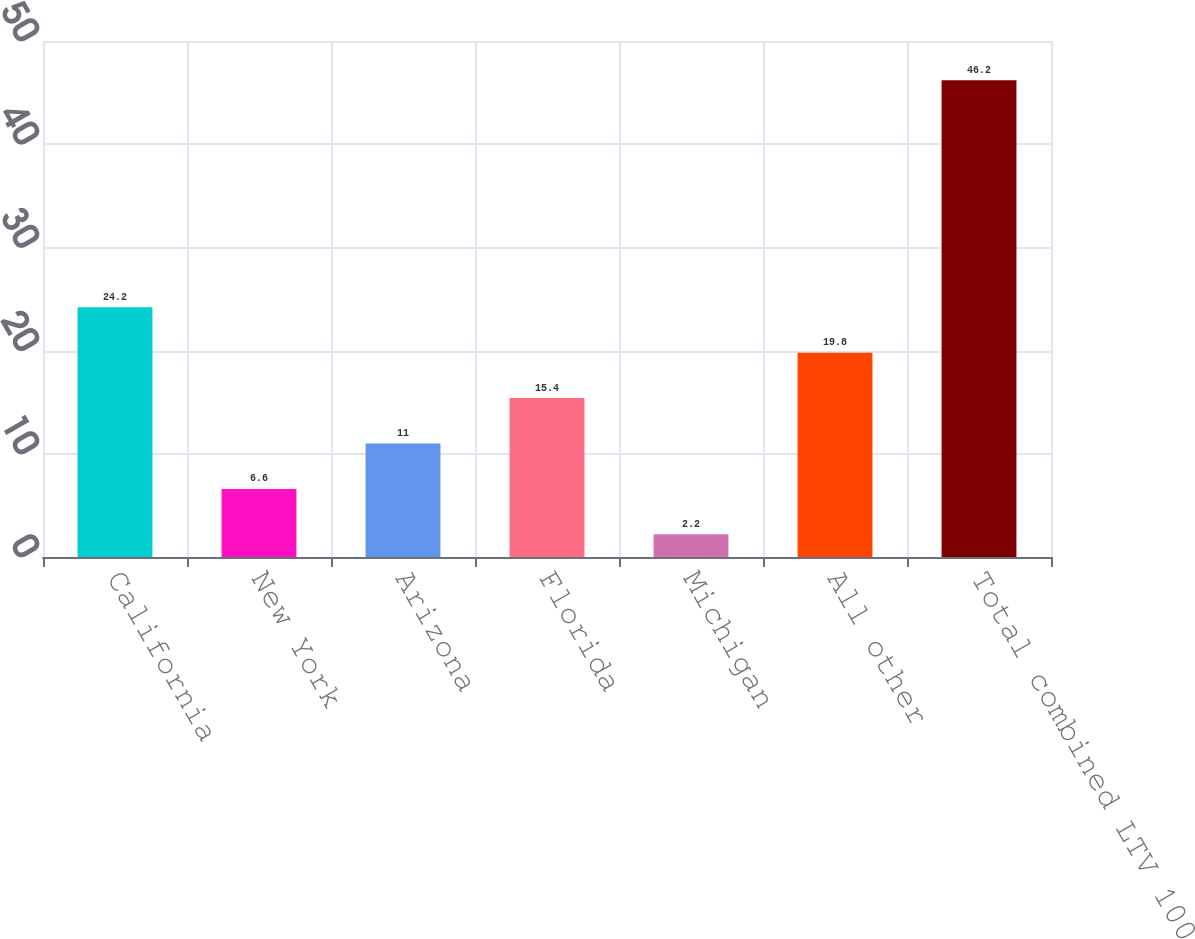Convert chart to OTSL. <chart><loc_0><loc_0><loc_500><loc_500><bar_chart><fcel>California<fcel>New York<fcel>Arizona<fcel>Florida<fcel>Michigan<fcel>All other<fcel>Total combined LTV 100<nl><fcel>24.2<fcel>6.6<fcel>11<fcel>15.4<fcel>2.2<fcel>19.8<fcel>46.2<nl></chart> 